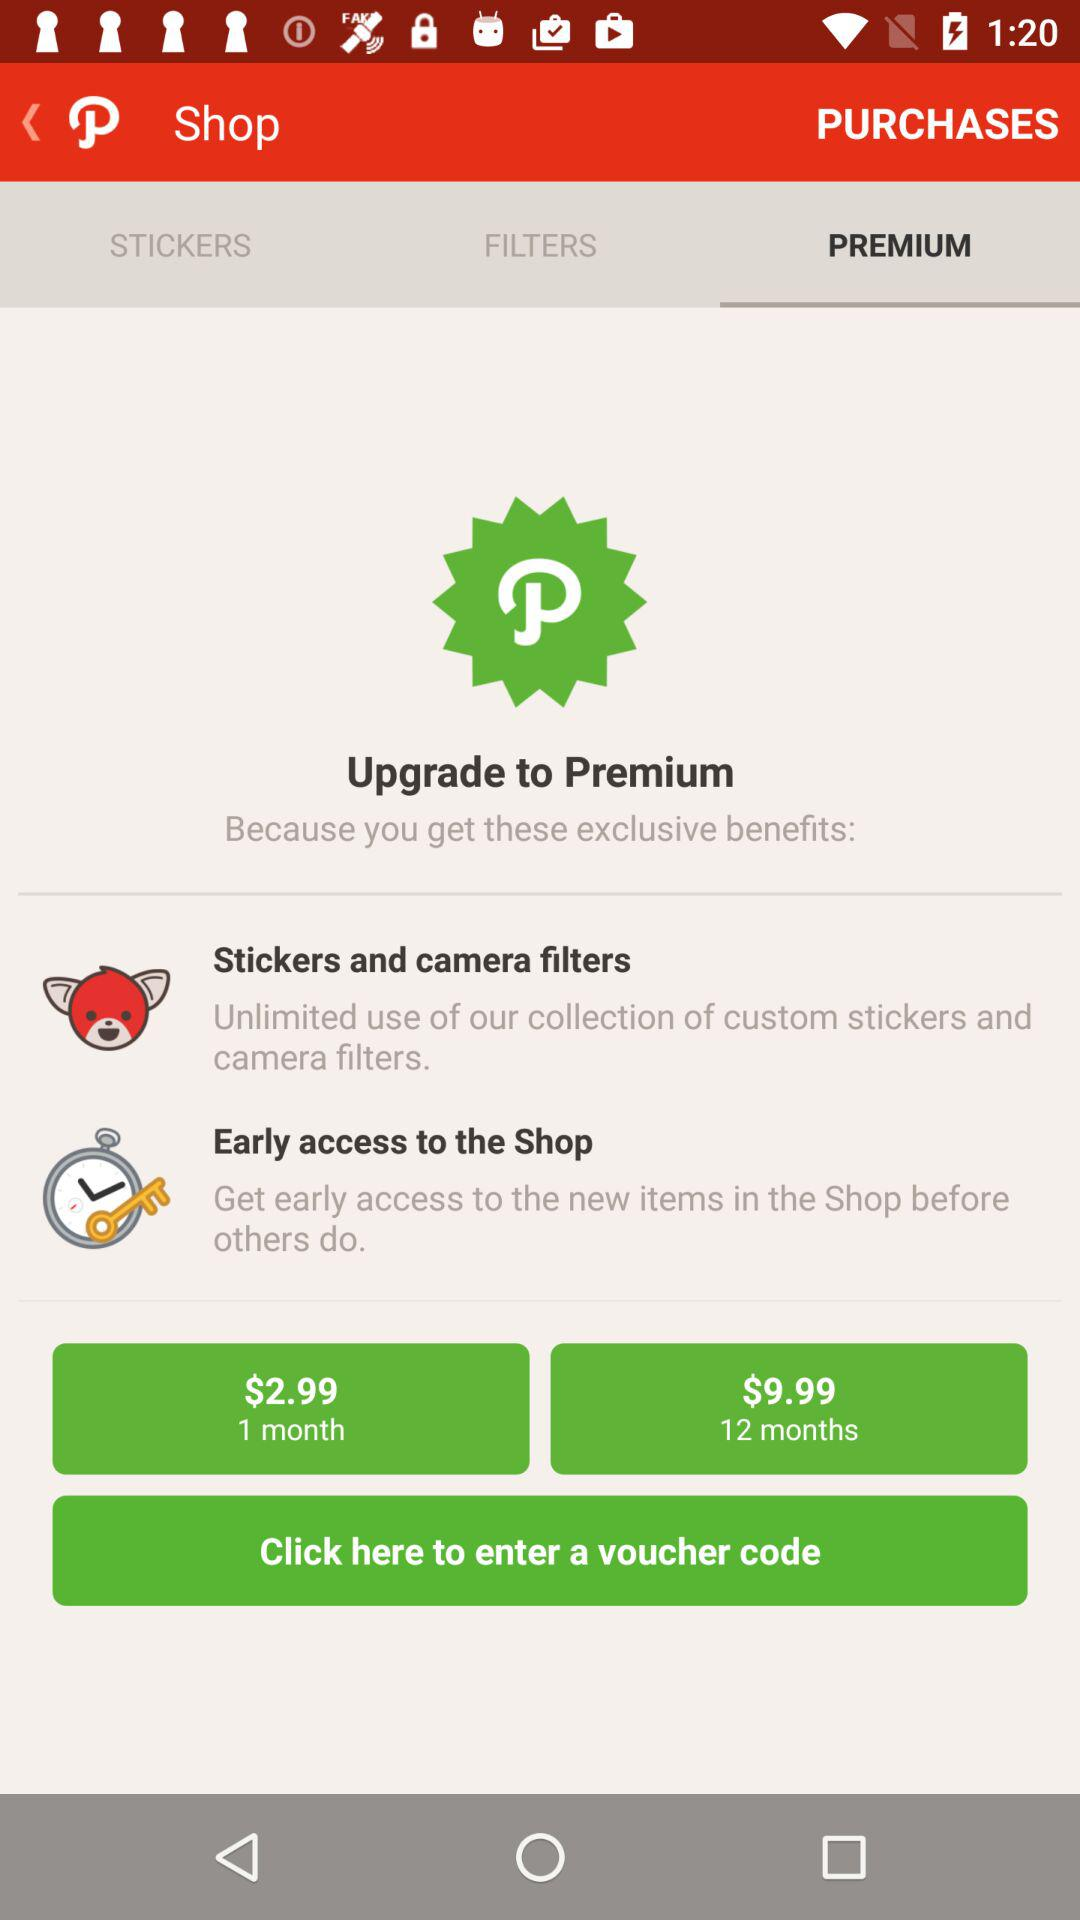What are the names of the different stickers?
When the provided information is insufficient, respond with <no answer>. <no answer> 